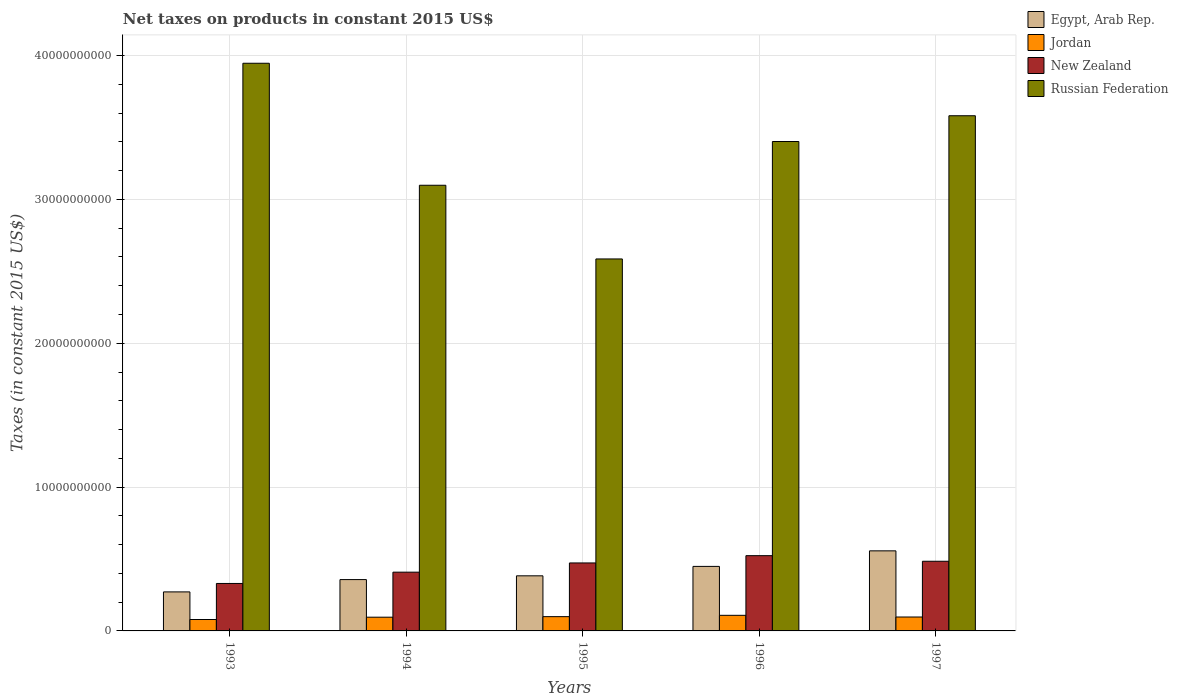What is the label of the 4th group of bars from the left?
Your answer should be very brief. 1996. In how many cases, is the number of bars for a given year not equal to the number of legend labels?
Provide a short and direct response. 0. What is the net taxes on products in Russian Federation in 1994?
Offer a very short reply. 3.10e+1. Across all years, what is the maximum net taxes on products in Jordan?
Your response must be concise. 1.08e+09. Across all years, what is the minimum net taxes on products in Jordan?
Give a very brief answer. 7.94e+08. In which year was the net taxes on products in Egypt, Arab Rep. maximum?
Offer a terse response. 1997. In which year was the net taxes on products in Egypt, Arab Rep. minimum?
Offer a terse response. 1993. What is the total net taxes on products in Jordan in the graph?
Your answer should be compact. 4.79e+09. What is the difference between the net taxes on products in New Zealand in 1996 and that in 1997?
Make the answer very short. 3.89e+08. What is the difference between the net taxes on products in New Zealand in 1996 and the net taxes on products in Jordan in 1995?
Give a very brief answer. 4.24e+09. What is the average net taxes on products in Egypt, Arab Rep. per year?
Offer a very short reply. 4.03e+09. In the year 1997, what is the difference between the net taxes on products in Jordan and net taxes on products in New Zealand?
Keep it short and to the point. -3.88e+09. What is the ratio of the net taxes on products in Egypt, Arab Rep. in 1994 to that in 1995?
Offer a very short reply. 0.93. What is the difference between the highest and the second highest net taxes on products in Egypt, Arab Rep.?
Your answer should be compact. 1.08e+09. What is the difference between the highest and the lowest net taxes on products in New Zealand?
Your answer should be compact. 1.93e+09. Is it the case that in every year, the sum of the net taxes on products in Jordan and net taxes on products in Egypt, Arab Rep. is greater than the sum of net taxes on products in New Zealand and net taxes on products in Russian Federation?
Make the answer very short. No. What does the 4th bar from the left in 1997 represents?
Give a very brief answer. Russian Federation. What does the 1st bar from the right in 1993 represents?
Provide a short and direct response. Russian Federation. Is it the case that in every year, the sum of the net taxes on products in Jordan and net taxes on products in Russian Federation is greater than the net taxes on products in New Zealand?
Offer a terse response. Yes. How many bars are there?
Offer a terse response. 20. Are all the bars in the graph horizontal?
Provide a short and direct response. No. How many years are there in the graph?
Keep it short and to the point. 5. How many legend labels are there?
Make the answer very short. 4. What is the title of the graph?
Keep it short and to the point. Net taxes on products in constant 2015 US$. What is the label or title of the X-axis?
Provide a succinct answer. Years. What is the label or title of the Y-axis?
Your response must be concise. Taxes (in constant 2015 US$). What is the Taxes (in constant 2015 US$) of Egypt, Arab Rep. in 1993?
Your response must be concise. 2.71e+09. What is the Taxes (in constant 2015 US$) in Jordan in 1993?
Offer a terse response. 7.94e+08. What is the Taxes (in constant 2015 US$) of New Zealand in 1993?
Provide a short and direct response. 3.30e+09. What is the Taxes (in constant 2015 US$) of Russian Federation in 1993?
Keep it short and to the point. 3.95e+1. What is the Taxes (in constant 2015 US$) in Egypt, Arab Rep. in 1994?
Offer a very short reply. 3.57e+09. What is the Taxes (in constant 2015 US$) in Jordan in 1994?
Your answer should be very brief. 9.55e+08. What is the Taxes (in constant 2015 US$) in New Zealand in 1994?
Provide a short and direct response. 4.08e+09. What is the Taxes (in constant 2015 US$) in Russian Federation in 1994?
Ensure brevity in your answer.  3.10e+1. What is the Taxes (in constant 2015 US$) of Egypt, Arab Rep. in 1995?
Make the answer very short. 3.83e+09. What is the Taxes (in constant 2015 US$) of Jordan in 1995?
Give a very brief answer. 9.92e+08. What is the Taxes (in constant 2015 US$) in New Zealand in 1995?
Offer a very short reply. 4.73e+09. What is the Taxes (in constant 2015 US$) of Russian Federation in 1995?
Your answer should be very brief. 2.59e+1. What is the Taxes (in constant 2015 US$) in Egypt, Arab Rep. in 1996?
Keep it short and to the point. 4.49e+09. What is the Taxes (in constant 2015 US$) of Jordan in 1996?
Provide a succinct answer. 1.08e+09. What is the Taxes (in constant 2015 US$) of New Zealand in 1996?
Your answer should be very brief. 5.23e+09. What is the Taxes (in constant 2015 US$) of Russian Federation in 1996?
Provide a short and direct response. 3.40e+1. What is the Taxes (in constant 2015 US$) of Egypt, Arab Rep. in 1997?
Offer a terse response. 5.57e+09. What is the Taxes (in constant 2015 US$) of Jordan in 1997?
Your answer should be very brief. 9.68e+08. What is the Taxes (in constant 2015 US$) in New Zealand in 1997?
Make the answer very short. 4.84e+09. What is the Taxes (in constant 2015 US$) in Russian Federation in 1997?
Make the answer very short. 3.58e+1. Across all years, what is the maximum Taxes (in constant 2015 US$) in Egypt, Arab Rep.?
Your answer should be compact. 5.57e+09. Across all years, what is the maximum Taxes (in constant 2015 US$) in Jordan?
Provide a succinct answer. 1.08e+09. Across all years, what is the maximum Taxes (in constant 2015 US$) of New Zealand?
Keep it short and to the point. 5.23e+09. Across all years, what is the maximum Taxes (in constant 2015 US$) in Russian Federation?
Ensure brevity in your answer.  3.95e+1. Across all years, what is the minimum Taxes (in constant 2015 US$) in Egypt, Arab Rep.?
Make the answer very short. 2.71e+09. Across all years, what is the minimum Taxes (in constant 2015 US$) in Jordan?
Give a very brief answer. 7.94e+08. Across all years, what is the minimum Taxes (in constant 2015 US$) in New Zealand?
Give a very brief answer. 3.30e+09. Across all years, what is the minimum Taxes (in constant 2015 US$) in Russian Federation?
Your answer should be compact. 2.59e+1. What is the total Taxes (in constant 2015 US$) in Egypt, Arab Rep. in the graph?
Give a very brief answer. 2.02e+1. What is the total Taxes (in constant 2015 US$) in Jordan in the graph?
Keep it short and to the point. 4.79e+09. What is the total Taxes (in constant 2015 US$) in New Zealand in the graph?
Keep it short and to the point. 2.22e+1. What is the total Taxes (in constant 2015 US$) of Russian Federation in the graph?
Your response must be concise. 1.66e+11. What is the difference between the Taxes (in constant 2015 US$) of Egypt, Arab Rep. in 1993 and that in 1994?
Provide a short and direct response. -8.55e+08. What is the difference between the Taxes (in constant 2015 US$) in Jordan in 1993 and that in 1994?
Keep it short and to the point. -1.61e+08. What is the difference between the Taxes (in constant 2015 US$) of New Zealand in 1993 and that in 1994?
Offer a very short reply. -7.85e+08. What is the difference between the Taxes (in constant 2015 US$) in Russian Federation in 1993 and that in 1994?
Provide a short and direct response. 8.48e+09. What is the difference between the Taxes (in constant 2015 US$) in Egypt, Arab Rep. in 1993 and that in 1995?
Your answer should be compact. -1.12e+09. What is the difference between the Taxes (in constant 2015 US$) of Jordan in 1993 and that in 1995?
Your answer should be very brief. -1.99e+08. What is the difference between the Taxes (in constant 2015 US$) in New Zealand in 1993 and that in 1995?
Keep it short and to the point. -1.43e+09. What is the difference between the Taxes (in constant 2015 US$) of Russian Federation in 1993 and that in 1995?
Make the answer very short. 1.36e+1. What is the difference between the Taxes (in constant 2015 US$) of Egypt, Arab Rep. in 1993 and that in 1996?
Your answer should be compact. -1.77e+09. What is the difference between the Taxes (in constant 2015 US$) in Jordan in 1993 and that in 1996?
Offer a very short reply. -2.91e+08. What is the difference between the Taxes (in constant 2015 US$) of New Zealand in 1993 and that in 1996?
Your answer should be very brief. -1.93e+09. What is the difference between the Taxes (in constant 2015 US$) of Russian Federation in 1993 and that in 1996?
Give a very brief answer. 5.44e+09. What is the difference between the Taxes (in constant 2015 US$) of Egypt, Arab Rep. in 1993 and that in 1997?
Your answer should be very brief. -2.85e+09. What is the difference between the Taxes (in constant 2015 US$) in Jordan in 1993 and that in 1997?
Give a very brief answer. -1.74e+08. What is the difference between the Taxes (in constant 2015 US$) in New Zealand in 1993 and that in 1997?
Offer a very short reply. -1.54e+09. What is the difference between the Taxes (in constant 2015 US$) in Russian Federation in 1993 and that in 1997?
Offer a very short reply. 3.65e+09. What is the difference between the Taxes (in constant 2015 US$) of Egypt, Arab Rep. in 1994 and that in 1995?
Offer a very short reply. -2.62e+08. What is the difference between the Taxes (in constant 2015 US$) in Jordan in 1994 and that in 1995?
Make the answer very short. -3.77e+07. What is the difference between the Taxes (in constant 2015 US$) of New Zealand in 1994 and that in 1995?
Provide a succinct answer. -6.41e+08. What is the difference between the Taxes (in constant 2015 US$) in Russian Federation in 1994 and that in 1995?
Give a very brief answer. 5.12e+09. What is the difference between the Taxes (in constant 2015 US$) of Egypt, Arab Rep. in 1994 and that in 1996?
Provide a succinct answer. -9.17e+08. What is the difference between the Taxes (in constant 2015 US$) in Jordan in 1994 and that in 1996?
Provide a succinct answer. -1.29e+08. What is the difference between the Taxes (in constant 2015 US$) in New Zealand in 1994 and that in 1996?
Your answer should be compact. -1.15e+09. What is the difference between the Taxes (in constant 2015 US$) of Russian Federation in 1994 and that in 1996?
Provide a short and direct response. -3.04e+09. What is the difference between the Taxes (in constant 2015 US$) in Egypt, Arab Rep. in 1994 and that in 1997?
Your answer should be very brief. -2.00e+09. What is the difference between the Taxes (in constant 2015 US$) in Jordan in 1994 and that in 1997?
Give a very brief answer. -1.31e+07. What is the difference between the Taxes (in constant 2015 US$) of New Zealand in 1994 and that in 1997?
Your response must be concise. -7.58e+08. What is the difference between the Taxes (in constant 2015 US$) in Russian Federation in 1994 and that in 1997?
Your answer should be compact. -4.83e+09. What is the difference between the Taxes (in constant 2015 US$) in Egypt, Arab Rep. in 1995 and that in 1996?
Provide a short and direct response. -6.55e+08. What is the difference between the Taxes (in constant 2015 US$) of Jordan in 1995 and that in 1996?
Your answer should be very brief. -9.18e+07. What is the difference between the Taxes (in constant 2015 US$) in New Zealand in 1995 and that in 1996?
Offer a very short reply. -5.06e+08. What is the difference between the Taxes (in constant 2015 US$) of Russian Federation in 1995 and that in 1996?
Make the answer very short. -8.16e+09. What is the difference between the Taxes (in constant 2015 US$) in Egypt, Arab Rep. in 1995 and that in 1997?
Ensure brevity in your answer.  -1.74e+09. What is the difference between the Taxes (in constant 2015 US$) in Jordan in 1995 and that in 1997?
Ensure brevity in your answer.  2.46e+07. What is the difference between the Taxes (in constant 2015 US$) of New Zealand in 1995 and that in 1997?
Provide a short and direct response. -1.17e+08. What is the difference between the Taxes (in constant 2015 US$) in Russian Federation in 1995 and that in 1997?
Offer a very short reply. -9.96e+09. What is the difference between the Taxes (in constant 2015 US$) of Egypt, Arab Rep. in 1996 and that in 1997?
Make the answer very short. -1.08e+09. What is the difference between the Taxes (in constant 2015 US$) of Jordan in 1996 and that in 1997?
Your response must be concise. 1.16e+08. What is the difference between the Taxes (in constant 2015 US$) in New Zealand in 1996 and that in 1997?
Your answer should be very brief. 3.89e+08. What is the difference between the Taxes (in constant 2015 US$) in Russian Federation in 1996 and that in 1997?
Offer a very short reply. -1.79e+09. What is the difference between the Taxes (in constant 2015 US$) in Egypt, Arab Rep. in 1993 and the Taxes (in constant 2015 US$) in Jordan in 1994?
Provide a short and direct response. 1.76e+09. What is the difference between the Taxes (in constant 2015 US$) of Egypt, Arab Rep. in 1993 and the Taxes (in constant 2015 US$) of New Zealand in 1994?
Offer a terse response. -1.37e+09. What is the difference between the Taxes (in constant 2015 US$) in Egypt, Arab Rep. in 1993 and the Taxes (in constant 2015 US$) in Russian Federation in 1994?
Give a very brief answer. -2.83e+1. What is the difference between the Taxes (in constant 2015 US$) of Jordan in 1993 and the Taxes (in constant 2015 US$) of New Zealand in 1994?
Give a very brief answer. -3.29e+09. What is the difference between the Taxes (in constant 2015 US$) in Jordan in 1993 and the Taxes (in constant 2015 US$) in Russian Federation in 1994?
Ensure brevity in your answer.  -3.02e+1. What is the difference between the Taxes (in constant 2015 US$) of New Zealand in 1993 and the Taxes (in constant 2015 US$) of Russian Federation in 1994?
Offer a very short reply. -2.77e+1. What is the difference between the Taxes (in constant 2015 US$) of Egypt, Arab Rep. in 1993 and the Taxes (in constant 2015 US$) of Jordan in 1995?
Make the answer very short. 1.72e+09. What is the difference between the Taxes (in constant 2015 US$) in Egypt, Arab Rep. in 1993 and the Taxes (in constant 2015 US$) in New Zealand in 1995?
Your answer should be compact. -2.01e+09. What is the difference between the Taxes (in constant 2015 US$) in Egypt, Arab Rep. in 1993 and the Taxes (in constant 2015 US$) in Russian Federation in 1995?
Make the answer very short. -2.31e+1. What is the difference between the Taxes (in constant 2015 US$) in Jordan in 1993 and the Taxes (in constant 2015 US$) in New Zealand in 1995?
Provide a short and direct response. -3.93e+09. What is the difference between the Taxes (in constant 2015 US$) in Jordan in 1993 and the Taxes (in constant 2015 US$) in Russian Federation in 1995?
Give a very brief answer. -2.51e+1. What is the difference between the Taxes (in constant 2015 US$) of New Zealand in 1993 and the Taxes (in constant 2015 US$) of Russian Federation in 1995?
Make the answer very short. -2.26e+1. What is the difference between the Taxes (in constant 2015 US$) in Egypt, Arab Rep. in 1993 and the Taxes (in constant 2015 US$) in Jordan in 1996?
Provide a succinct answer. 1.63e+09. What is the difference between the Taxes (in constant 2015 US$) in Egypt, Arab Rep. in 1993 and the Taxes (in constant 2015 US$) in New Zealand in 1996?
Offer a very short reply. -2.52e+09. What is the difference between the Taxes (in constant 2015 US$) in Egypt, Arab Rep. in 1993 and the Taxes (in constant 2015 US$) in Russian Federation in 1996?
Make the answer very short. -3.13e+1. What is the difference between the Taxes (in constant 2015 US$) of Jordan in 1993 and the Taxes (in constant 2015 US$) of New Zealand in 1996?
Offer a terse response. -4.44e+09. What is the difference between the Taxes (in constant 2015 US$) of Jordan in 1993 and the Taxes (in constant 2015 US$) of Russian Federation in 1996?
Offer a very short reply. -3.32e+1. What is the difference between the Taxes (in constant 2015 US$) in New Zealand in 1993 and the Taxes (in constant 2015 US$) in Russian Federation in 1996?
Give a very brief answer. -3.07e+1. What is the difference between the Taxes (in constant 2015 US$) of Egypt, Arab Rep. in 1993 and the Taxes (in constant 2015 US$) of Jordan in 1997?
Your answer should be compact. 1.75e+09. What is the difference between the Taxes (in constant 2015 US$) in Egypt, Arab Rep. in 1993 and the Taxes (in constant 2015 US$) in New Zealand in 1997?
Make the answer very short. -2.13e+09. What is the difference between the Taxes (in constant 2015 US$) of Egypt, Arab Rep. in 1993 and the Taxes (in constant 2015 US$) of Russian Federation in 1997?
Provide a succinct answer. -3.31e+1. What is the difference between the Taxes (in constant 2015 US$) in Jordan in 1993 and the Taxes (in constant 2015 US$) in New Zealand in 1997?
Give a very brief answer. -4.05e+09. What is the difference between the Taxes (in constant 2015 US$) in Jordan in 1993 and the Taxes (in constant 2015 US$) in Russian Federation in 1997?
Make the answer very short. -3.50e+1. What is the difference between the Taxes (in constant 2015 US$) in New Zealand in 1993 and the Taxes (in constant 2015 US$) in Russian Federation in 1997?
Offer a very short reply. -3.25e+1. What is the difference between the Taxes (in constant 2015 US$) in Egypt, Arab Rep. in 1994 and the Taxes (in constant 2015 US$) in Jordan in 1995?
Make the answer very short. 2.58e+09. What is the difference between the Taxes (in constant 2015 US$) of Egypt, Arab Rep. in 1994 and the Taxes (in constant 2015 US$) of New Zealand in 1995?
Your answer should be compact. -1.16e+09. What is the difference between the Taxes (in constant 2015 US$) of Egypt, Arab Rep. in 1994 and the Taxes (in constant 2015 US$) of Russian Federation in 1995?
Make the answer very short. -2.23e+1. What is the difference between the Taxes (in constant 2015 US$) of Jordan in 1994 and the Taxes (in constant 2015 US$) of New Zealand in 1995?
Offer a very short reply. -3.77e+09. What is the difference between the Taxes (in constant 2015 US$) in Jordan in 1994 and the Taxes (in constant 2015 US$) in Russian Federation in 1995?
Ensure brevity in your answer.  -2.49e+1. What is the difference between the Taxes (in constant 2015 US$) in New Zealand in 1994 and the Taxes (in constant 2015 US$) in Russian Federation in 1995?
Make the answer very short. -2.18e+1. What is the difference between the Taxes (in constant 2015 US$) in Egypt, Arab Rep. in 1994 and the Taxes (in constant 2015 US$) in Jordan in 1996?
Provide a succinct answer. 2.48e+09. What is the difference between the Taxes (in constant 2015 US$) of Egypt, Arab Rep. in 1994 and the Taxes (in constant 2015 US$) of New Zealand in 1996?
Your answer should be compact. -1.66e+09. What is the difference between the Taxes (in constant 2015 US$) in Egypt, Arab Rep. in 1994 and the Taxes (in constant 2015 US$) in Russian Federation in 1996?
Offer a very short reply. -3.05e+1. What is the difference between the Taxes (in constant 2015 US$) of Jordan in 1994 and the Taxes (in constant 2015 US$) of New Zealand in 1996?
Provide a short and direct response. -4.28e+09. What is the difference between the Taxes (in constant 2015 US$) of Jordan in 1994 and the Taxes (in constant 2015 US$) of Russian Federation in 1996?
Provide a succinct answer. -3.31e+1. What is the difference between the Taxes (in constant 2015 US$) in New Zealand in 1994 and the Taxes (in constant 2015 US$) in Russian Federation in 1996?
Provide a short and direct response. -2.99e+1. What is the difference between the Taxes (in constant 2015 US$) of Egypt, Arab Rep. in 1994 and the Taxes (in constant 2015 US$) of Jordan in 1997?
Your answer should be very brief. 2.60e+09. What is the difference between the Taxes (in constant 2015 US$) of Egypt, Arab Rep. in 1994 and the Taxes (in constant 2015 US$) of New Zealand in 1997?
Provide a short and direct response. -1.27e+09. What is the difference between the Taxes (in constant 2015 US$) in Egypt, Arab Rep. in 1994 and the Taxes (in constant 2015 US$) in Russian Federation in 1997?
Ensure brevity in your answer.  -3.22e+1. What is the difference between the Taxes (in constant 2015 US$) of Jordan in 1994 and the Taxes (in constant 2015 US$) of New Zealand in 1997?
Your answer should be very brief. -3.89e+09. What is the difference between the Taxes (in constant 2015 US$) of Jordan in 1994 and the Taxes (in constant 2015 US$) of Russian Federation in 1997?
Keep it short and to the point. -3.49e+1. What is the difference between the Taxes (in constant 2015 US$) of New Zealand in 1994 and the Taxes (in constant 2015 US$) of Russian Federation in 1997?
Offer a terse response. -3.17e+1. What is the difference between the Taxes (in constant 2015 US$) of Egypt, Arab Rep. in 1995 and the Taxes (in constant 2015 US$) of Jordan in 1996?
Offer a terse response. 2.75e+09. What is the difference between the Taxes (in constant 2015 US$) in Egypt, Arab Rep. in 1995 and the Taxes (in constant 2015 US$) in New Zealand in 1996?
Keep it short and to the point. -1.40e+09. What is the difference between the Taxes (in constant 2015 US$) in Egypt, Arab Rep. in 1995 and the Taxes (in constant 2015 US$) in Russian Federation in 1996?
Keep it short and to the point. -3.02e+1. What is the difference between the Taxes (in constant 2015 US$) in Jordan in 1995 and the Taxes (in constant 2015 US$) in New Zealand in 1996?
Make the answer very short. -4.24e+09. What is the difference between the Taxes (in constant 2015 US$) of Jordan in 1995 and the Taxes (in constant 2015 US$) of Russian Federation in 1996?
Give a very brief answer. -3.30e+1. What is the difference between the Taxes (in constant 2015 US$) in New Zealand in 1995 and the Taxes (in constant 2015 US$) in Russian Federation in 1996?
Your answer should be very brief. -2.93e+1. What is the difference between the Taxes (in constant 2015 US$) of Egypt, Arab Rep. in 1995 and the Taxes (in constant 2015 US$) of Jordan in 1997?
Make the answer very short. 2.86e+09. What is the difference between the Taxes (in constant 2015 US$) in Egypt, Arab Rep. in 1995 and the Taxes (in constant 2015 US$) in New Zealand in 1997?
Keep it short and to the point. -1.01e+09. What is the difference between the Taxes (in constant 2015 US$) of Egypt, Arab Rep. in 1995 and the Taxes (in constant 2015 US$) of Russian Federation in 1997?
Offer a terse response. -3.20e+1. What is the difference between the Taxes (in constant 2015 US$) of Jordan in 1995 and the Taxes (in constant 2015 US$) of New Zealand in 1997?
Offer a very short reply. -3.85e+09. What is the difference between the Taxes (in constant 2015 US$) of Jordan in 1995 and the Taxes (in constant 2015 US$) of Russian Federation in 1997?
Provide a succinct answer. -3.48e+1. What is the difference between the Taxes (in constant 2015 US$) of New Zealand in 1995 and the Taxes (in constant 2015 US$) of Russian Federation in 1997?
Your response must be concise. -3.11e+1. What is the difference between the Taxes (in constant 2015 US$) of Egypt, Arab Rep. in 1996 and the Taxes (in constant 2015 US$) of Jordan in 1997?
Provide a short and direct response. 3.52e+09. What is the difference between the Taxes (in constant 2015 US$) of Egypt, Arab Rep. in 1996 and the Taxes (in constant 2015 US$) of New Zealand in 1997?
Offer a very short reply. -3.58e+08. What is the difference between the Taxes (in constant 2015 US$) of Egypt, Arab Rep. in 1996 and the Taxes (in constant 2015 US$) of Russian Federation in 1997?
Your answer should be very brief. -3.13e+1. What is the difference between the Taxes (in constant 2015 US$) in Jordan in 1996 and the Taxes (in constant 2015 US$) in New Zealand in 1997?
Ensure brevity in your answer.  -3.76e+09. What is the difference between the Taxes (in constant 2015 US$) of Jordan in 1996 and the Taxes (in constant 2015 US$) of Russian Federation in 1997?
Give a very brief answer. -3.47e+1. What is the difference between the Taxes (in constant 2015 US$) in New Zealand in 1996 and the Taxes (in constant 2015 US$) in Russian Federation in 1997?
Provide a short and direct response. -3.06e+1. What is the average Taxes (in constant 2015 US$) of Egypt, Arab Rep. per year?
Your response must be concise. 4.03e+09. What is the average Taxes (in constant 2015 US$) of Jordan per year?
Make the answer very short. 9.59e+08. What is the average Taxes (in constant 2015 US$) of New Zealand per year?
Your response must be concise. 4.44e+09. What is the average Taxes (in constant 2015 US$) in Russian Federation per year?
Give a very brief answer. 3.32e+1. In the year 1993, what is the difference between the Taxes (in constant 2015 US$) of Egypt, Arab Rep. and Taxes (in constant 2015 US$) of Jordan?
Your answer should be compact. 1.92e+09. In the year 1993, what is the difference between the Taxes (in constant 2015 US$) of Egypt, Arab Rep. and Taxes (in constant 2015 US$) of New Zealand?
Your answer should be compact. -5.87e+08. In the year 1993, what is the difference between the Taxes (in constant 2015 US$) of Egypt, Arab Rep. and Taxes (in constant 2015 US$) of Russian Federation?
Provide a short and direct response. -3.68e+1. In the year 1993, what is the difference between the Taxes (in constant 2015 US$) of Jordan and Taxes (in constant 2015 US$) of New Zealand?
Keep it short and to the point. -2.51e+09. In the year 1993, what is the difference between the Taxes (in constant 2015 US$) in Jordan and Taxes (in constant 2015 US$) in Russian Federation?
Offer a terse response. -3.87e+1. In the year 1993, what is the difference between the Taxes (in constant 2015 US$) in New Zealand and Taxes (in constant 2015 US$) in Russian Federation?
Your answer should be very brief. -3.62e+1. In the year 1994, what is the difference between the Taxes (in constant 2015 US$) of Egypt, Arab Rep. and Taxes (in constant 2015 US$) of Jordan?
Keep it short and to the point. 2.61e+09. In the year 1994, what is the difference between the Taxes (in constant 2015 US$) in Egypt, Arab Rep. and Taxes (in constant 2015 US$) in New Zealand?
Offer a very short reply. -5.16e+08. In the year 1994, what is the difference between the Taxes (in constant 2015 US$) of Egypt, Arab Rep. and Taxes (in constant 2015 US$) of Russian Federation?
Make the answer very short. -2.74e+1. In the year 1994, what is the difference between the Taxes (in constant 2015 US$) of Jordan and Taxes (in constant 2015 US$) of New Zealand?
Your answer should be compact. -3.13e+09. In the year 1994, what is the difference between the Taxes (in constant 2015 US$) in Jordan and Taxes (in constant 2015 US$) in Russian Federation?
Provide a succinct answer. -3.00e+1. In the year 1994, what is the difference between the Taxes (in constant 2015 US$) of New Zealand and Taxes (in constant 2015 US$) of Russian Federation?
Keep it short and to the point. -2.69e+1. In the year 1995, what is the difference between the Taxes (in constant 2015 US$) of Egypt, Arab Rep. and Taxes (in constant 2015 US$) of Jordan?
Provide a succinct answer. 2.84e+09. In the year 1995, what is the difference between the Taxes (in constant 2015 US$) of Egypt, Arab Rep. and Taxes (in constant 2015 US$) of New Zealand?
Your response must be concise. -8.95e+08. In the year 1995, what is the difference between the Taxes (in constant 2015 US$) of Egypt, Arab Rep. and Taxes (in constant 2015 US$) of Russian Federation?
Offer a very short reply. -2.20e+1. In the year 1995, what is the difference between the Taxes (in constant 2015 US$) in Jordan and Taxes (in constant 2015 US$) in New Zealand?
Ensure brevity in your answer.  -3.73e+09. In the year 1995, what is the difference between the Taxes (in constant 2015 US$) in Jordan and Taxes (in constant 2015 US$) in Russian Federation?
Your answer should be very brief. -2.49e+1. In the year 1995, what is the difference between the Taxes (in constant 2015 US$) in New Zealand and Taxes (in constant 2015 US$) in Russian Federation?
Ensure brevity in your answer.  -2.11e+1. In the year 1996, what is the difference between the Taxes (in constant 2015 US$) in Egypt, Arab Rep. and Taxes (in constant 2015 US$) in Jordan?
Your answer should be very brief. 3.40e+09. In the year 1996, what is the difference between the Taxes (in constant 2015 US$) in Egypt, Arab Rep. and Taxes (in constant 2015 US$) in New Zealand?
Offer a very short reply. -7.47e+08. In the year 1996, what is the difference between the Taxes (in constant 2015 US$) in Egypt, Arab Rep. and Taxes (in constant 2015 US$) in Russian Federation?
Your answer should be compact. -2.95e+1. In the year 1996, what is the difference between the Taxes (in constant 2015 US$) in Jordan and Taxes (in constant 2015 US$) in New Zealand?
Your answer should be compact. -4.15e+09. In the year 1996, what is the difference between the Taxes (in constant 2015 US$) of Jordan and Taxes (in constant 2015 US$) of Russian Federation?
Make the answer very short. -3.29e+1. In the year 1996, what is the difference between the Taxes (in constant 2015 US$) in New Zealand and Taxes (in constant 2015 US$) in Russian Federation?
Keep it short and to the point. -2.88e+1. In the year 1997, what is the difference between the Taxes (in constant 2015 US$) of Egypt, Arab Rep. and Taxes (in constant 2015 US$) of Jordan?
Give a very brief answer. 4.60e+09. In the year 1997, what is the difference between the Taxes (in constant 2015 US$) in Egypt, Arab Rep. and Taxes (in constant 2015 US$) in New Zealand?
Give a very brief answer. 7.24e+08. In the year 1997, what is the difference between the Taxes (in constant 2015 US$) of Egypt, Arab Rep. and Taxes (in constant 2015 US$) of Russian Federation?
Make the answer very short. -3.02e+1. In the year 1997, what is the difference between the Taxes (in constant 2015 US$) of Jordan and Taxes (in constant 2015 US$) of New Zealand?
Your answer should be compact. -3.88e+09. In the year 1997, what is the difference between the Taxes (in constant 2015 US$) in Jordan and Taxes (in constant 2015 US$) in Russian Federation?
Your response must be concise. -3.48e+1. In the year 1997, what is the difference between the Taxes (in constant 2015 US$) of New Zealand and Taxes (in constant 2015 US$) of Russian Federation?
Offer a terse response. -3.10e+1. What is the ratio of the Taxes (in constant 2015 US$) in Egypt, Arab Rep. in 1993 to that in 1994?
Offer a very short reply. 0.76. What is the ratio of the Taxes (in constant 2015 US$) of Jordan in 1993 to that in 1994?
Your answer should be very brief. 0.83. What is the ratio of the Taxes (in constant 2015 US$) in New Zealand in 1993 to that in 1994?
Offer a very short reply. 0.81. What is the ratio of the Taxes (in constant 2015 US$) in Russian Federation in 1993 to that in 1994?
Your answer should be compact. 1.27. What is the ratio of the Taxes (in constant 2015 US$) of Egypt, Arab Rep. in 1993 to that in 1995?
Offer a very short reply. 0.71. What is the ratio of the Taxes (in constant 2015 US$) in Jordan in 1993 to that in 1995?
Keep it short and to the point. 0.8. What is the ratio of the Taxes (in constant 2015 US$) in New Zealand in 1993 to that in 1995?
Ensure brevity in your answer.  0.7. What is the ratio of the Taxes (in constant 2015 US$) of Russian Federation in 1993 to that in 1995?
Keep it short and to the point. 1.53. What is the ratio of the Taxes (in constant 2015 US$) of Egypt, Arab Rep. in 1993 to that in 1996?
Keep it short and to the point. 0.6. What is the ratio of the Taxes (in constant 2015 US$) in Jordan in 1993 to that in 1996?
Give a very brief answer. 0.73. What is the ratio of the Taxes (in constant 2015 US$) in New Zealand in 1993 to that in 1996?
Offer a terse response. 0.63. What is the ratio of the Taxes (in constant 2015 US$) in Russian Federation in 1993 to that in 1996?
Keep it short and to the point. 1.16. What is the ratio of the Taxes (in constant 2015 US$) of Egypt, Arab Rep. in 1993 to that in 1997?
Offer a terse response. 0.49. What is the ratio of the Taxes (in constant 2015 US$) in Jordan in 1993 to that in 1997?
Make the answer very short. 0.82. What is the ratio of the Taxes (in constant 2015 US$) of New Zealand in 1993 to that in 1997?
Offer a terse response. 0.68. What is the ratio of the Taxes (in constant 2015 US$) in Russian Federation in 1993 to that in 1997?
Your answer should be very brief. 1.1. What is the ratio of the Taxes (in constant 2015 US$) of Egypt, Arab Rep. in 1994 to that in 1995?
Provide a succinct answer. 0.93. What is the ratio of the Taxes (in constant 2015 US$) of New Zealand in 1994 to that in 1995?
Ensure brevity in your answer.  0.86. What is the ratio of the Taxes (in constant 2015 US$) in Russian Federation in 1994 to that in 1995?
Offer a very short reply. 1.2. What is the ratio of the Taxes (in constant 2015 US$) in Egypt, Arab Rep. in 1994 to that in 1996?
Give a very brief answer. 0.8. What is the ratio of the Taxes (in constant 2015 US$) in Jordan in 1994 to that in 1996?
Your answer should be very brief. 0.88. What is the ratio of the Taxes (in constant 2015 US$) of New Zealand in 1994 to that in 1996?
Your response must be concise. 0.78. What is the ratio of the Taxes (in constant 2015 US$) of Russian Federation in 1994 to that in 1996?
Your response must be concise. 0.91. What is the ratio of the Taxes (in constant 2015 US$) of Egypt, Arab Rep. in 1994 to that in 1997?
Ensure brevity in your answer.  0.64. What is the ratio of the Taxes (in constant 2015 US$) of Jordan in 1994 to that in 1997?
Your answer should be very brief. 0.99. What is the ratio of the Taxes (in constant 2015 US$) of New Zealand in 1994 to that in 1997?
Your answer should be very brief. 0.84. What is the ratio of the Taxes (in constant 2015 US$) of Russian Federation in 1994 to that in 1997?
Your answer should be compact. 0.87. What is the ratio of the Taxes (in constant 2015 US$) in Egypt, Arab Rep. in 1995 to that in 1996?
Make the answer very short. 0.85. What is the ratio of the Taxes (in constant 2015 US$) of Jordan in 1995 to that in 1996?
Your answer should be compact. 0.92. What is the ratio of the Taxes (in constant 2015 US$) in New Zealand in 1995 to that in 1996?
Your answer should be very brief. 0.9. What is the ratio of the Taxes (in constant 2015 US$) of Russian Federation in 1995 to that in 1996?
Make the answer very short. 0.76. What is the ratio of the Taxes (in constant 2015 US$) of Egypt, Arab Rep. in 1995 to that in 1997?
Provide a succinct answer. 0.69. What is the ratio of the Taxes (in constant 2015 US$) in Jordan in 1995 to that in 1997?
Provide a short and direct response. 1.03. What is the ratio of the Taxes (in constant 2015 US$) of New Zealand in 1995 to that in 1997?
Offer a terse response. 0.98. What is the ratio of the Taxes (in constant 2015 US$) of Russian Federation in 1995 to that in 1997?
Provide a succinct answer. 0.72. What is the ratio of the Taxes (in constant 2015 US$) of Egypt, Arab Rep. in 1996 to that in 1997?
Give a very brief answer. 0.81. What is the ratio of the Taxes (in constant 2015 US$) in Jordan in 1996 to that in 1997?
Offer a very short reply. 1.12. What is the ratio of the Taxes (in constant 2015 US$) of New Zealand in 1996 to that in 1997?
Give a very brief answer. 1.08. What is the ratio of the Taxes (in constant 2015 US$) of Russian Federation in 1996 to that in 1997?
Your response must be concise. 0.95. What is the difference between the highest and the second highest Taxes (in constant 2015 US$) in Egypt, Arab Rep.?
Your answer should be very brief. 1.08e+09. What is the difference between the highest and the second highest Taxes (in constant 2015 US$) of Jordan?
Keep it short and to the point. 9.18e+07. What is the difference between the highest and the second highest Taxes (in constant 2015 US$) of New Zealand?
Provide a short and direct response. 3.89e+08. What is the difference between the highest and the second highest Taxes (in constant 2015 US$) in Russian Federation?
Keep it short and to the point. 3.65e+09. What is the difference between the highest and the lowest Taxes (in constant 2015 US$) in Egypt, Arab Rep.?
Provide a short and direct response. 2.85e+09. What is the difference between the highest and the lowest Taxes (in constant 2015 US$) in Jordan?
Provide a succinct answer. 2.91e+08. What is the difference between the highest and the lowest Taxes (in constant 2015 US$) of New Zealand?
Your answer should be very brief. 1.93e+09. What is the difference between the highest and the lowest Taxes (in constant 2015 US$) of Russian Federation?
Provide a short and direct response. 1.36e+1. 